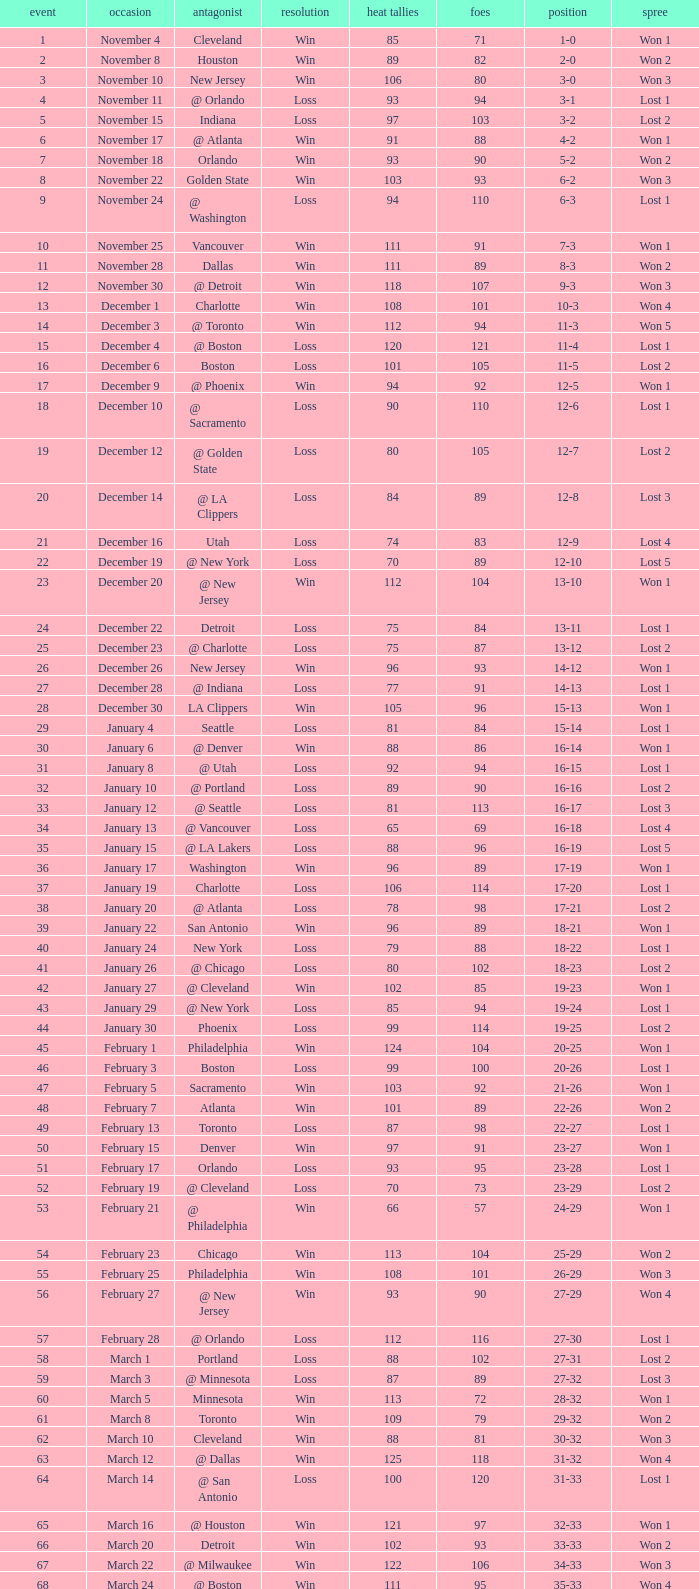What is Streak, when Heat Points is "101", and when Game is "16"? Lost 2. 